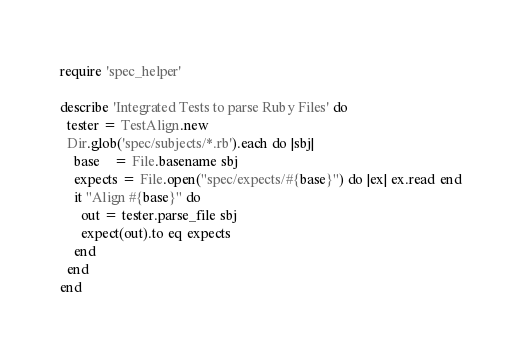<code> <loc_0><loc_0><loc_500><loc_500><_Ruby_>require 'spec_helper'

describe 'Integrated Tests to parse Ruby Files' do
  tester = TestAlign.new
  Dir.glob('spec/subjects/*.rb').each do |sbj|
    base    = File.basename sbj
    expects = File.open("spec/expects/#{base}") do |ex| ex.read end
    it "Align #{base}" do
      out = tester.parse_file sbj
      expect(out).to eq expects
    end
  end
end
</code> 